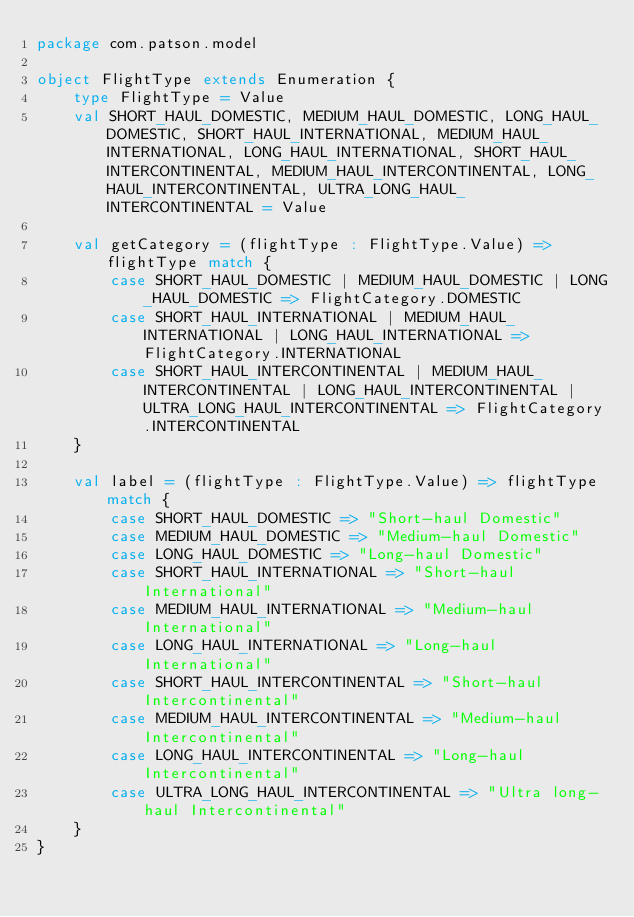Convert code to text. <code><loc_0><loc_0><loc_500><loc_500><_Scala_>package com.patson.model

object FlightType extends Enumeration {
    type FlightType = Value
    val SHORT_HAUL_DOMESTIC, MEDIUM_HAUL_DOMESTIC, LONG_HAUL_DOMESTIC, SHORT_HAUL_INTERNATIONAL, MEDIUM_HAUL_INTERNATIONAL, LONG_HAUL_INTERNATIONAL, SHORT_HAUL_INTERCONTINENTAL, MEDIUM_HAUL_INTERCONTINENTAL, LONG_HAUL_INTERCONTINENTAL, ULTRA_LONG_HAUL_INTERCONTINENTAL = Value

    val getCategory = (flightType : FlightType.Value) => flightType match {
        case SHORT_HAUL_DOMESTIC | MEDIUM_HAUL_DOMESTIC | LONG_HAUL_DOMESTIC => FlightCategory.DOMESTIC
        case SHORT_HAUL_INTERNATIONAL | MEDIUM_HAUL_INTERNATIONAL | LONG_HAUL_INTERNATIONAL => FlightCategory.INTERNATIONAL
        case SHORT_HAUL_INTERCONTINENTAL | MEDIUM_HAUL_INTERCONTINENTAL | LONG_HAUL_INTERCONTINENTAL | ULTRA_LONG_HAUL_INTERCONTINENTAL => FlightCategory.INTERCONTINENTAL
    }

    val label = (flightType : FlightType.Value) => flightType match {
        case SHORT_HAUL_DOMESTIC => "Short-haul Domestic"
        case MEDIUM_HAUL_DOMESTIC => "Medium-haul Domestic"
        case LONG_HAUL_DOMESTIC => "Long-haul Domestic"
        case SHORT_HAUL_INTERNATIONAL => "Short-haul International"
        case MEDIUM_HAUL_INTERNATIONAL => "Medium-haul International"
        case LONG_HAUL_INTERNATIONAL => "Long-haul International"
        case SHORT_HAUL_INTERCONTINENTAL => "Short-haul Intercontinental"
        case MEDIUM_HAUL_INTERCONTINENTAL => "Medium-haul Intercontinental"
        case LONG_HAUL_INTERCONTINENTAL => "Long-haul Intercontinental"
        case ULTRA_LONG_HAUL_INTERCONTINENTAL => "Ultra long-haul Intercontinental"
    }
}</code> 